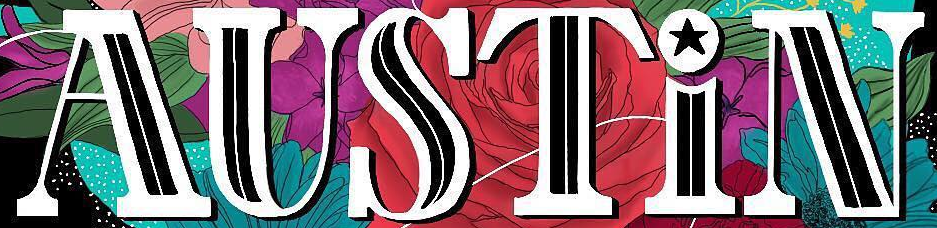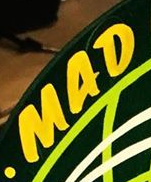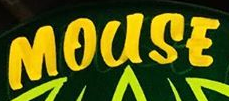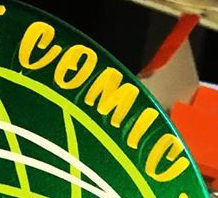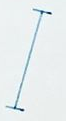Identify the words shown in these images in order, separated by a semicolon. AUSTiN; MAD; MOUSE; COMIC; I 